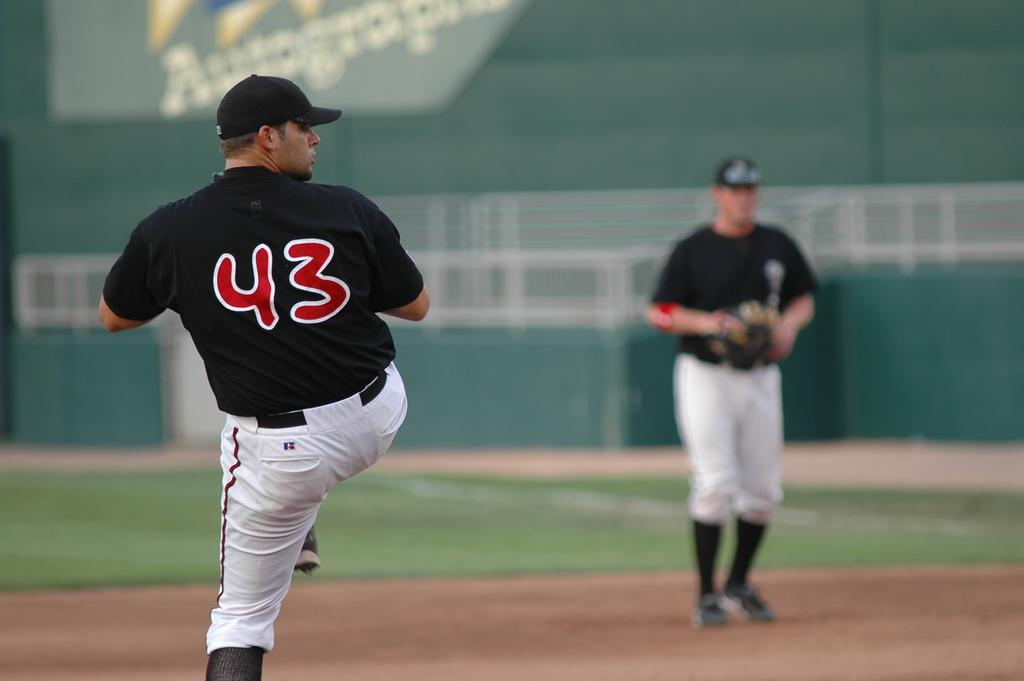Provide a one-sentence caption for the provided image. A left handed pitcher getting ready to throw wearing #43. 